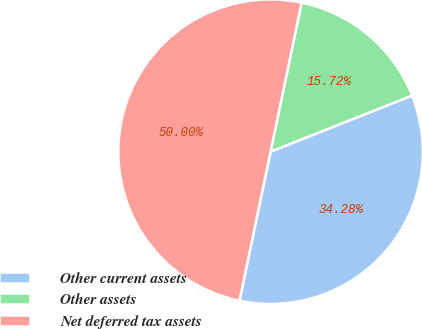Convert chart. <chart><loc_0><loc_0><loc_500><loc_500><pie_chart><fcel>Other current assets<fcel>Other assets<fcel>Net deferred tax assets<nl><fcel>34.28%<fcel>15.72%<fcel>50.0%<nl></chart> 